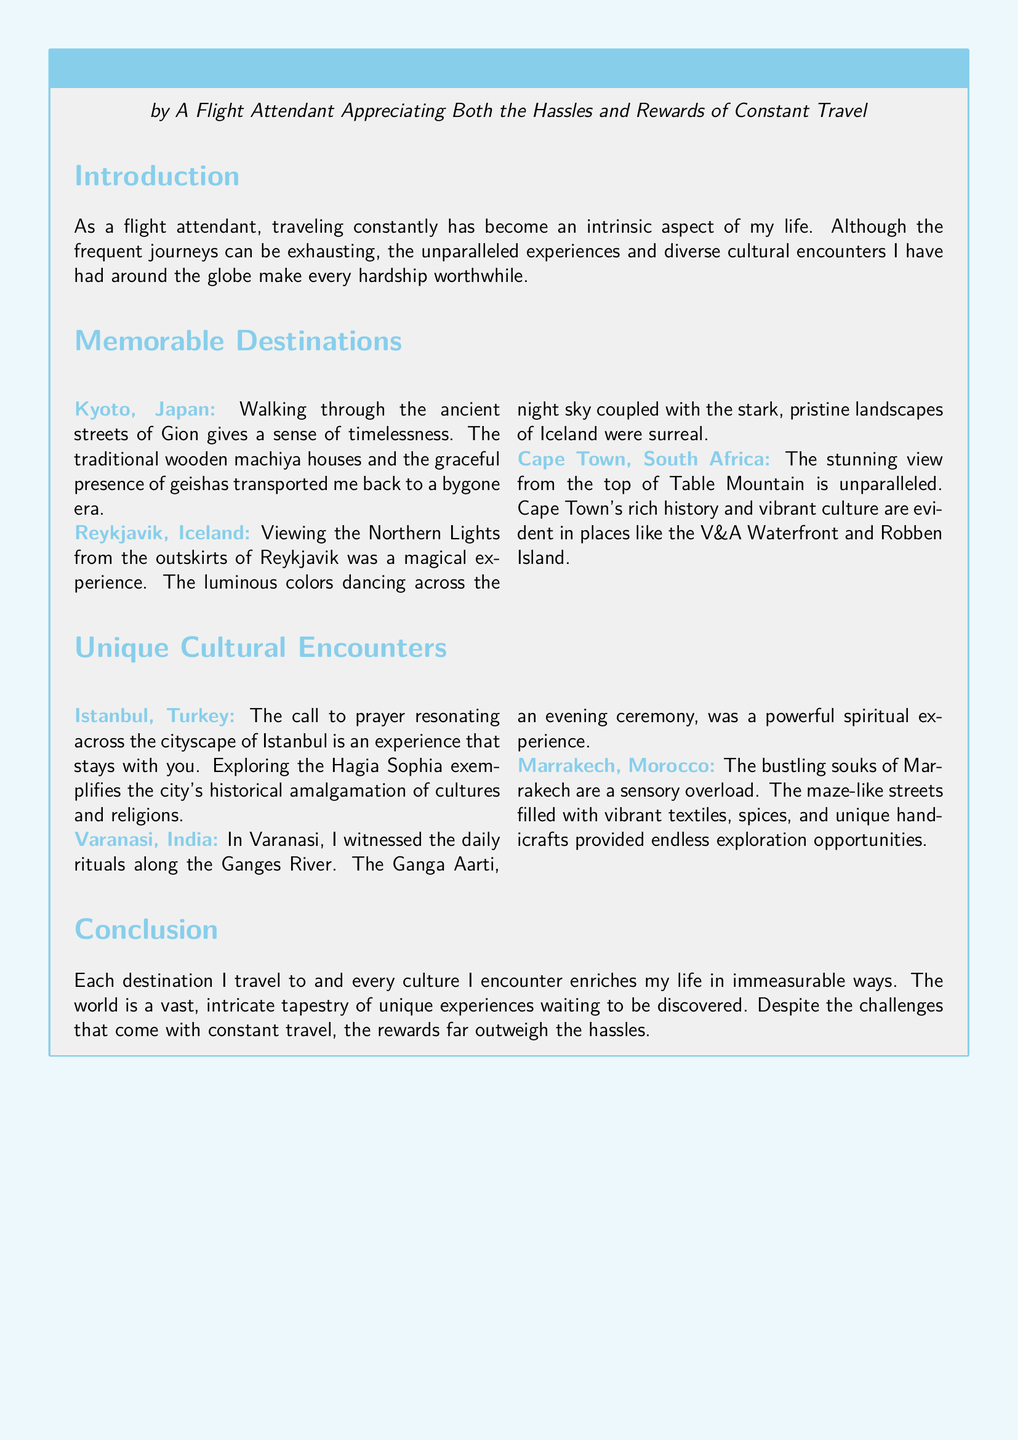What is the title of the document? The title of the document is mentioned at the beginning of the tcolorbox.
Answer: Declaration of Personal Travel Experiences Who is the author of the document? The author is specified right underneath the title in the document.
Answer: A Flight Attendant Appreciating Both the Hassles and Rewards of Constant Travel Which destination is known for its ancient streets of Gion? The destination is identified in the section about memorable places in the document.
Answer: Kyoto, Japan What unique cultural encounter involves the Ganges River? This cultural encounter is described in the section about unique cultural encounters.
Answer: Varanasi, India Which city offers a view of the Northern Lights? The city is specified in the memorable destinations section of the document.
Answer: Reykjavik, Iceland What is highlighted as a powerful spiritual experience in the document? This experience involves a specific ritual mentioned in the unique cultural encounters.
Answer: Ganga Aarti How many destinations are listed in the document? The number of destinations can be counted from the memorable destinations section.
Answer: Three Which cultural encounter describes a sensory overload? This is identified in the unique cultural encounters section of the document.
Answer: Marrakech, Morocco What is the concluding sentiment about travel in the document? The conclusion summarizes the author's feelings regarding the hassles and rewards of travel.
Answer: The rewards far outweigh the hassles 